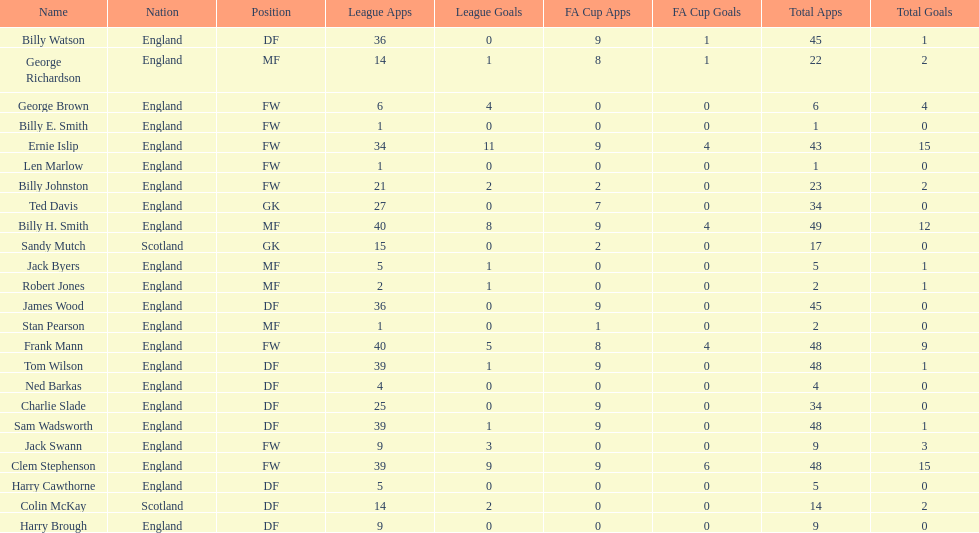Which position is listed the least amount of times on this chart? GK. 